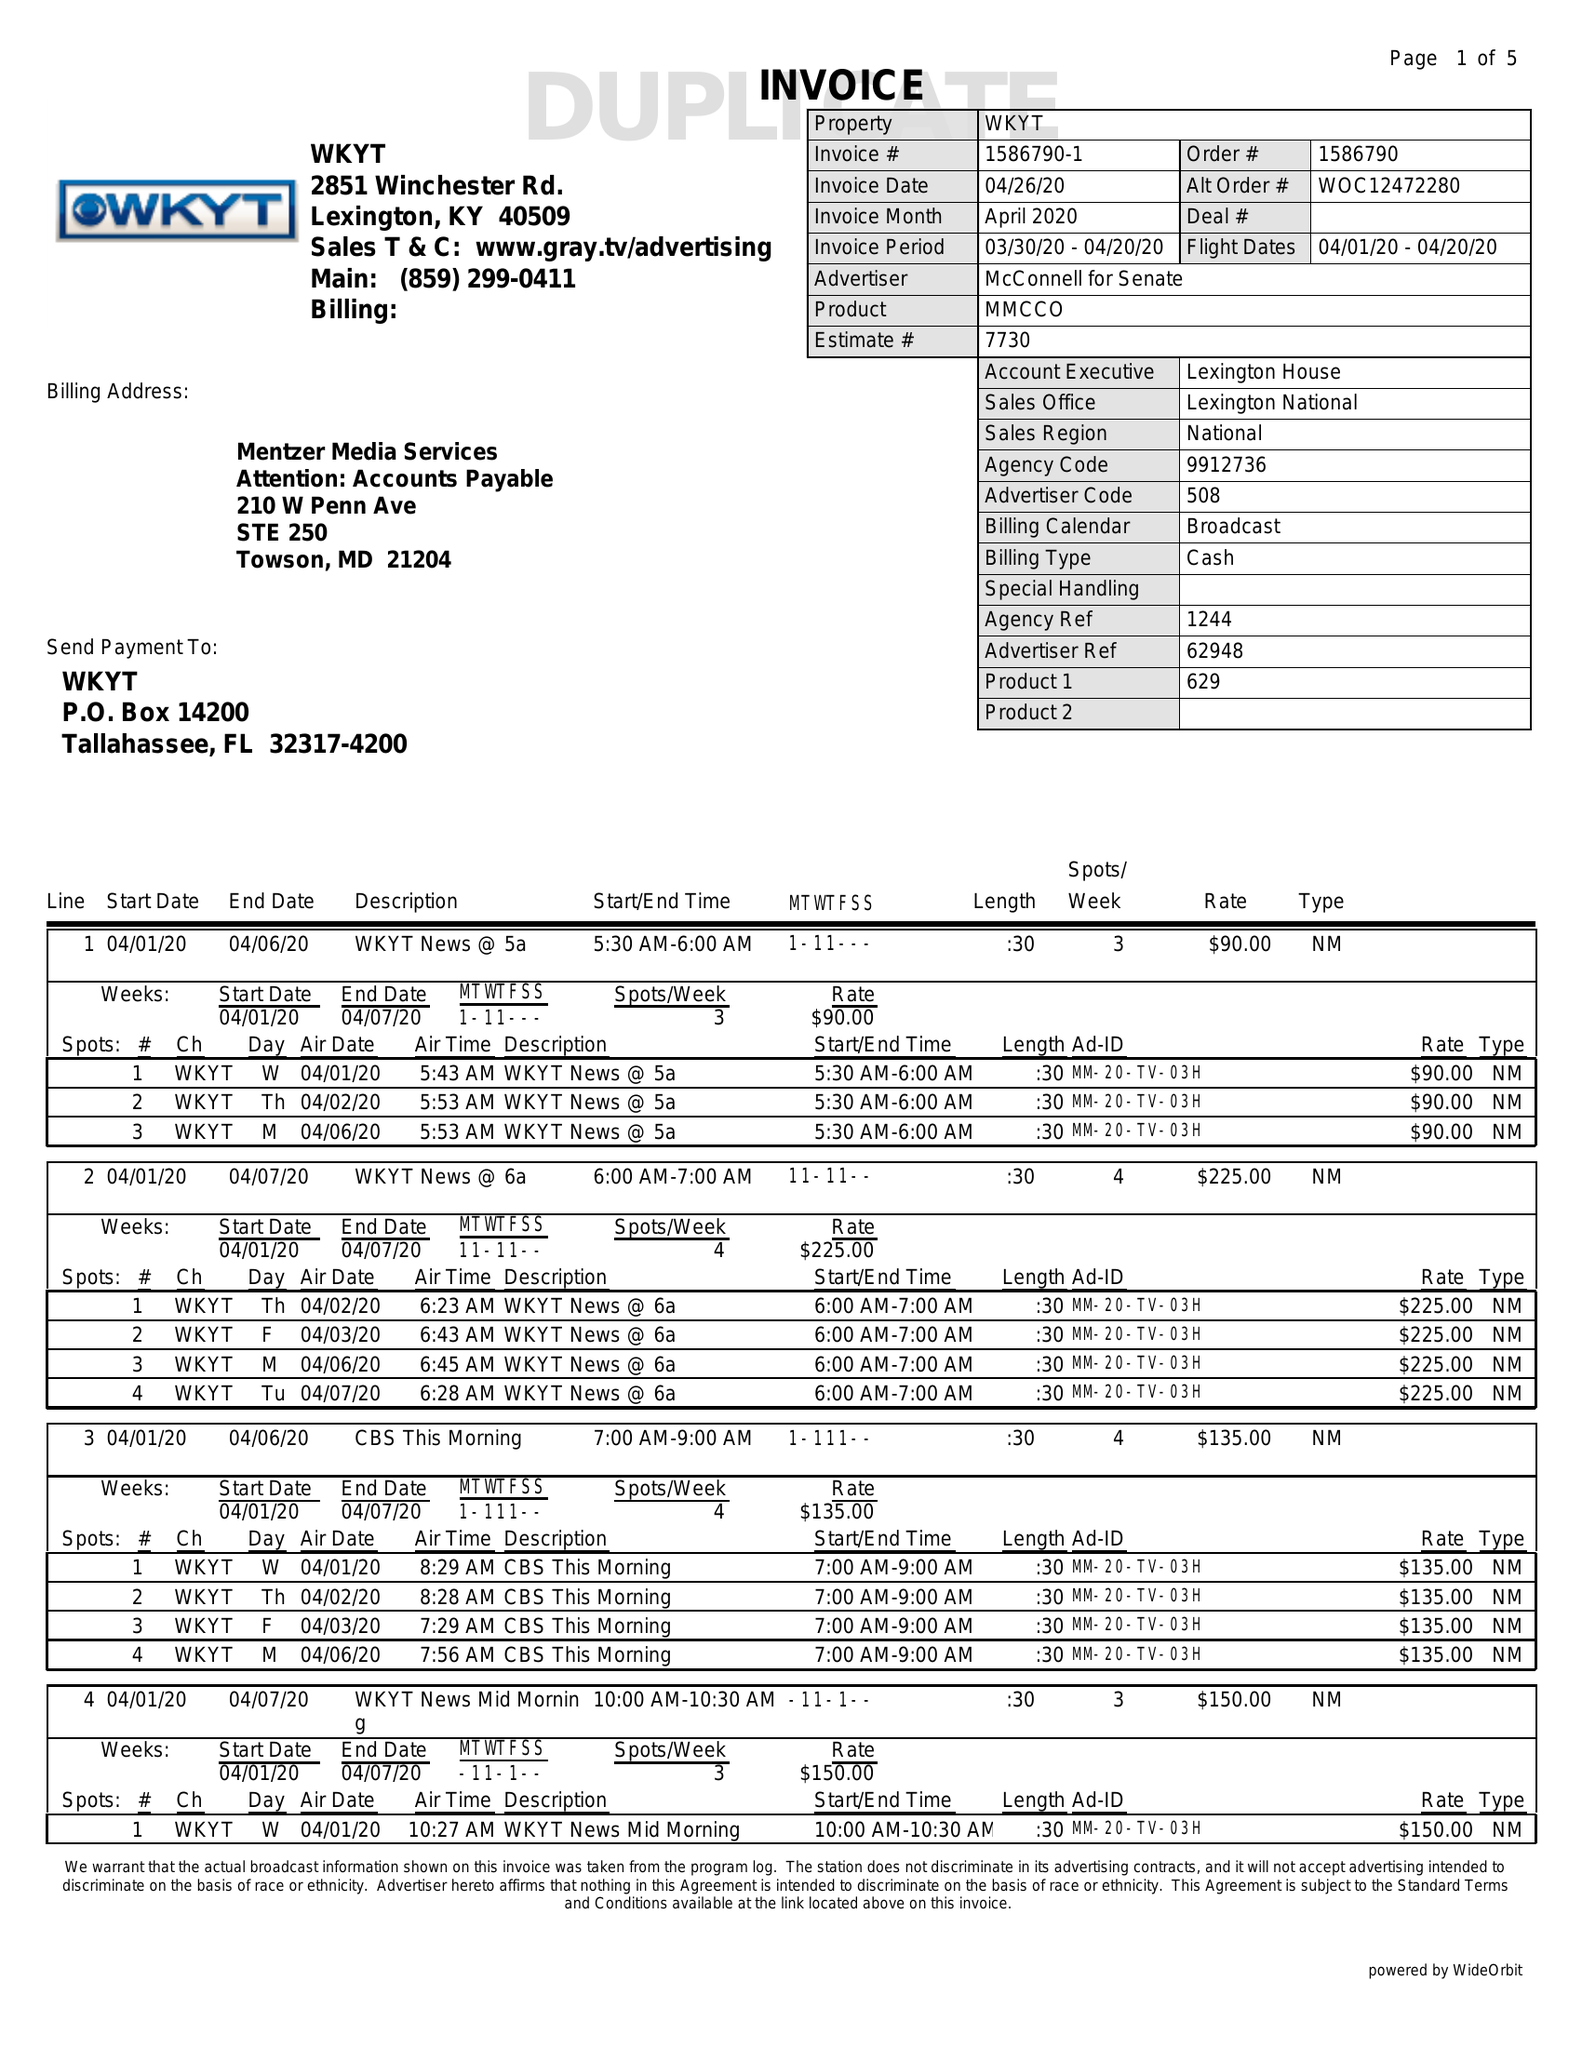What is the value for the advertiser?
Answer the question using a single word or phrase. MCCONNELL FOR SENATE 